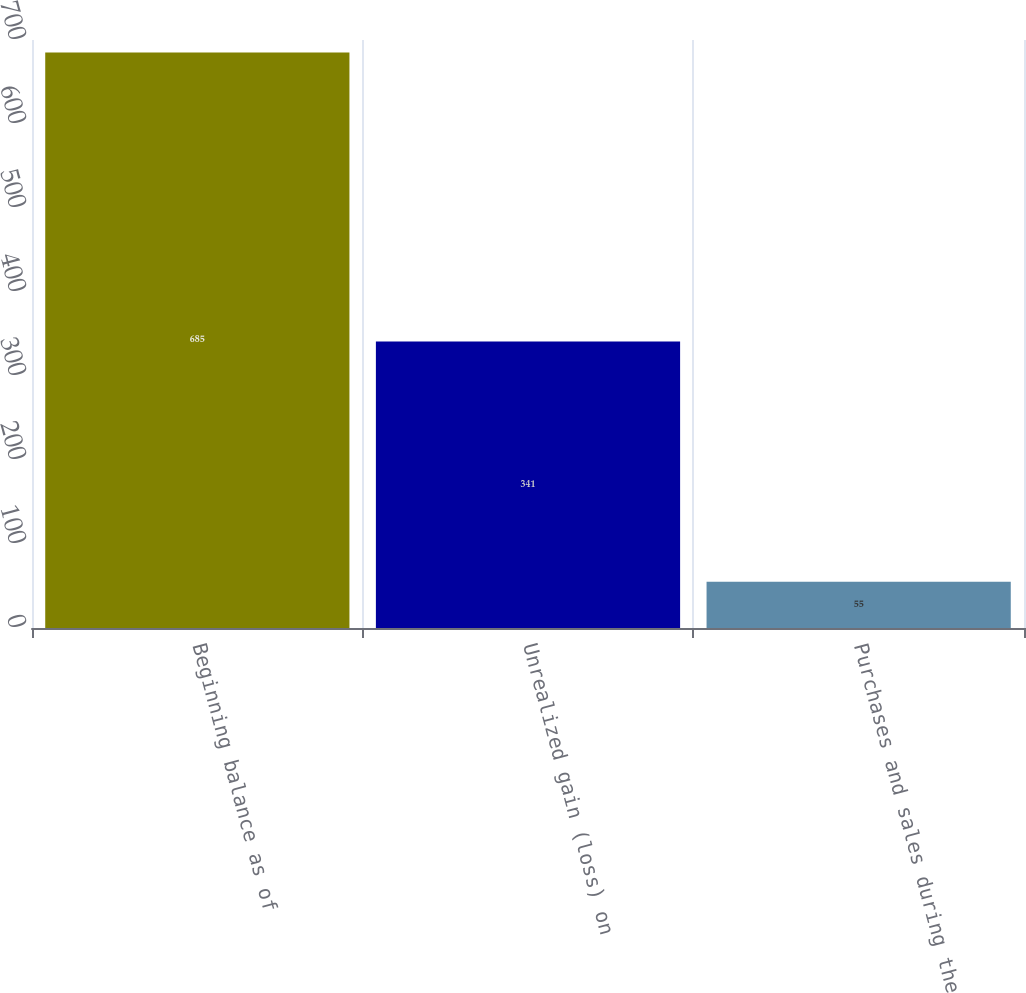Convert chart. <chart><loc_0><loc_0><loc_500><loc_500><bar_chart><fcel>Beginning balance as of<fcel>Unrealized gain (loss) on<fcel>Purchases and sales during the<nl><fcel>685<fcel>341<fcel>55<nl></chart> 